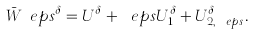<formula> <loc_0><loc_0><loc_500><loc_500>\bar { W } _ { \ } e p s ^ { \delta } = U ^ { \delta } + \ e p s U _ { 1 } ^ { \delta } + U _ { 2 , \ e p s } ^ { \delta } .</formula> 